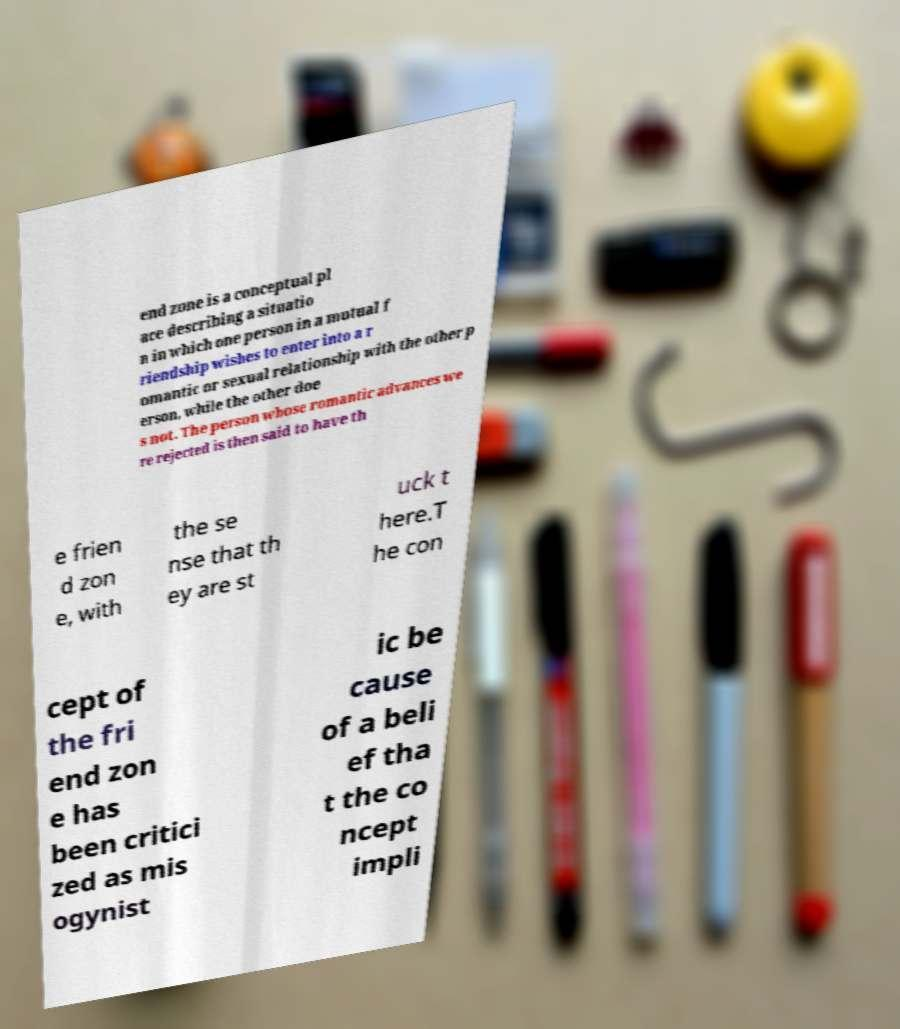What messages or text are displayed in this image? I need them in a readable, typed format. end zone is a conceptual pl ace describing a situatio n in which one person in a mutual f riendship wishes to enter into a r omantic or sexual relationship with the other p erson, while the other doe s not. The person whose romantic advances we re rejected is then said to have th e frien d zon e, with the se nse that th ey are st uck t here.T he con cept of the fri end zon e has been critici zed as mis ogynist ic be cause of a beli ef tha t the co ncept impli 